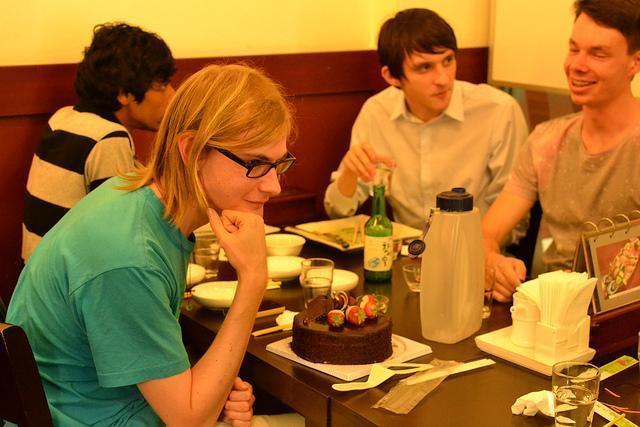How many people?
Give a very brief answer. 4. How many hands can be seen?
Give a very brief answer. 4. How many bottles can you see?
Give a very brief answer. 2. How many people are there?
Give a very brief answer. 4. 